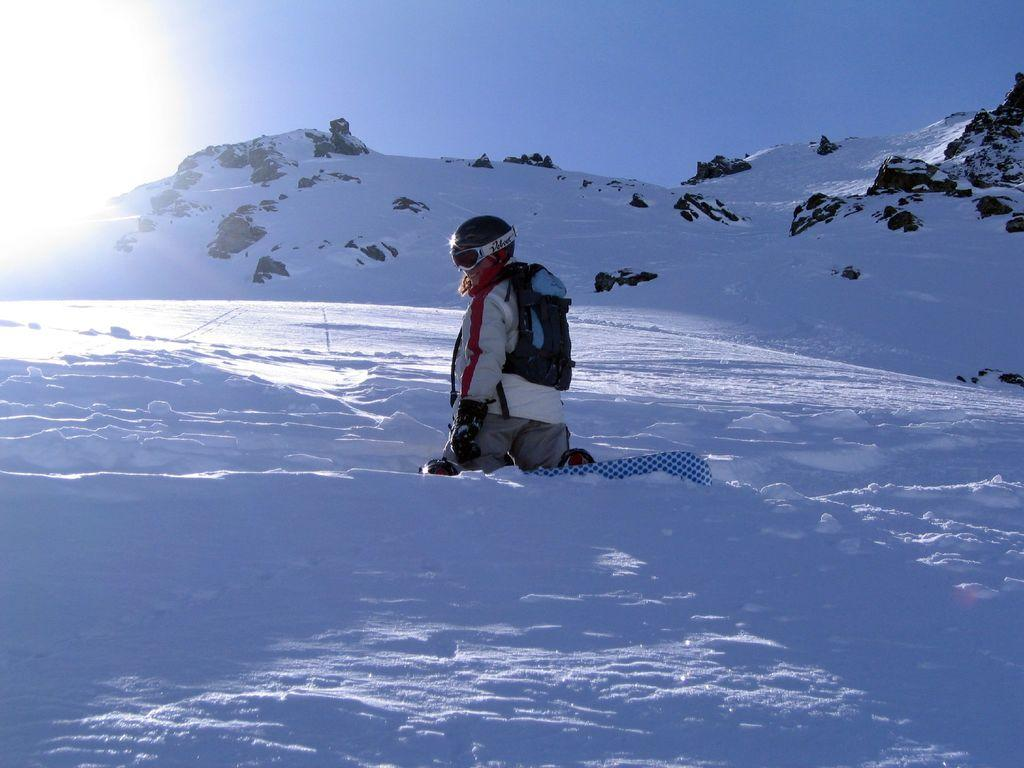What is the main subject of the image? There is a person in the image. What is the person doing in the image? The person is sitting on their knees on the snow. What can be seen in the background of the image? There is a mountain in the background of the image. What is the condition of the mountain in the image? The mountain is covered with snow. What type of throat lozenges can be seen in the image? There are no throat lozenges present in the image. 